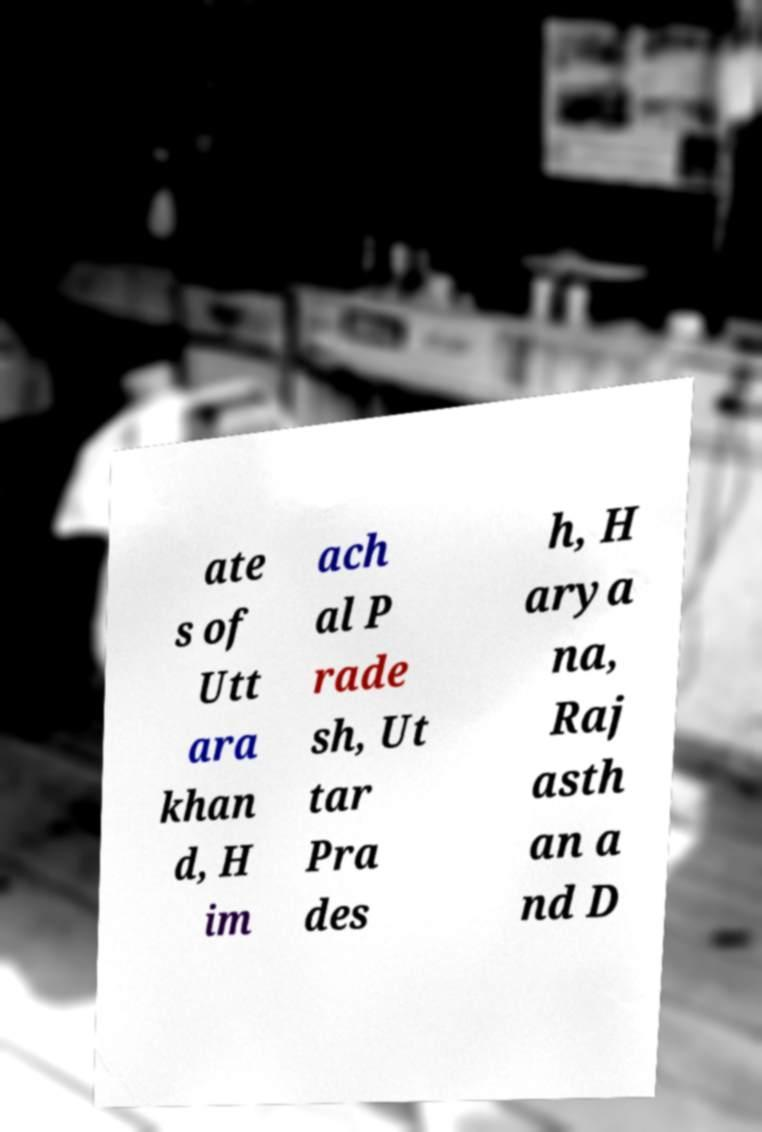Can you accurately transcribe the text from the provided image for me? ate s of Utt ara khan d, H im ach al P rade sh, Ut tar Pra des h, H arya na, Raj asth an a nd D 